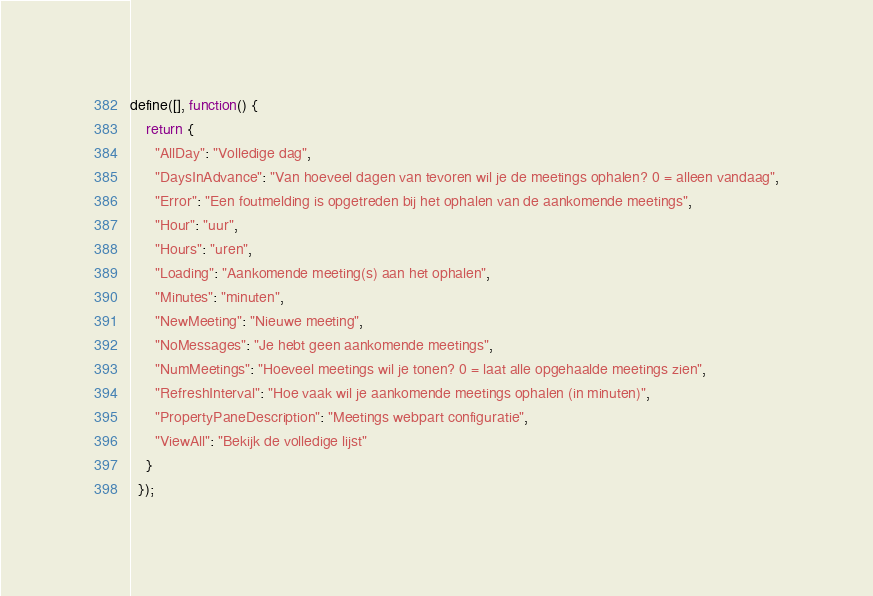Convert code to text. <code><loc_0><loc_0><loc_500><loc_500><_JavaScript_>define([], function() {
    return {
      "AllDay": "Volledige dag",
      "DaysInAdvance": "Van hoeveel dagen van tevoren wil je de meetings ophalen? 0 = alleen vandaag",
      "Error": "Een foutmelding is opgetreden bij het ophalen van de aankomende meetings",
      "Hour": "uur",
      "Hours": "uren",
      "Loading": "Aankomende meeting(s) aan het ophalen",
      "Minutes": "minuten",
      "NewMeeting": "Nieuwe meeting",
      "NoMessages": "Je hebt geen aankomende meetings",
      "NumMeetings": "Hoeveel meetings wil je tonen? 0 = laat alle opgehaalde meetings zien",
      "RefreshInterval": "Hoe vaak wil je aankomende meetings ophalen (in minuten)",
      "PropertyPaneDescription": "Meetings webpart configuratie",
      "ViewAll": "Bekijk de volledige lijst"
    }
  });</code> 